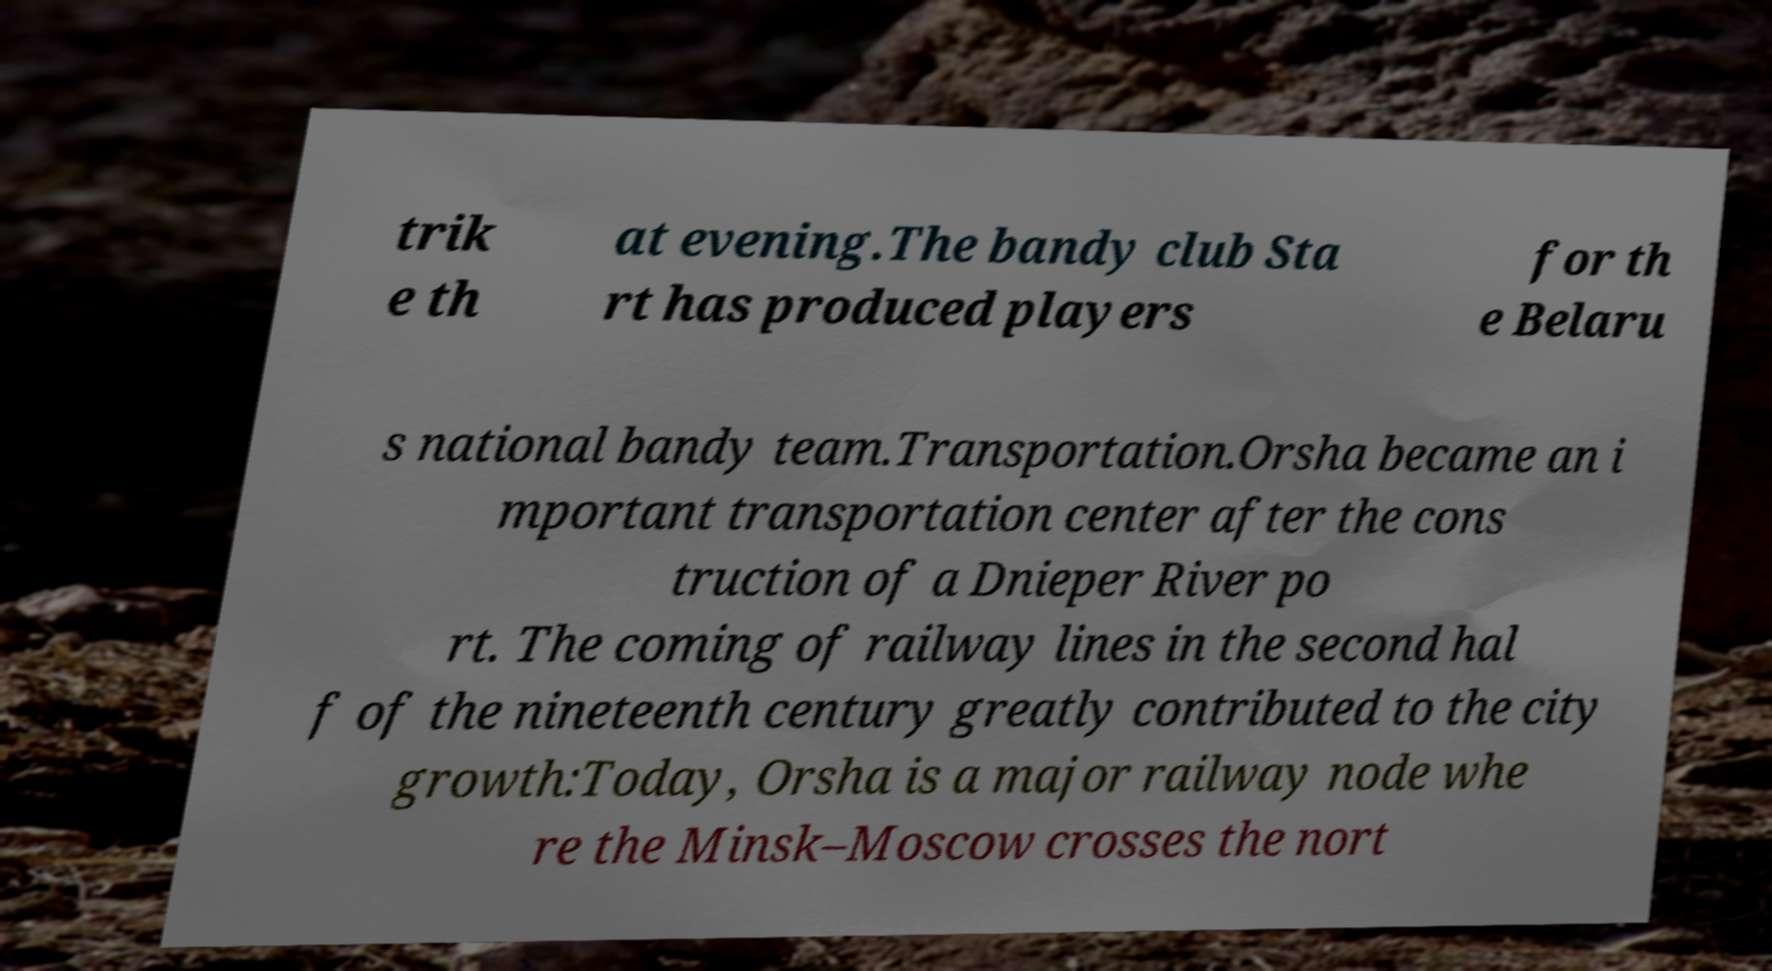Please read and relay the text visible in this image. What does it say? trik e th at evening.The bandy club Sta rt has produced players for th e Belaru s national bandy team.Transportation.Orsha became an i mportant transportation center after the cons truction of a Dnieper River po rt. The coming of railway lines in the second hal f of the nineteenth century greatly contributed to the city growth:Today, Orsha is a major railway node whe re the Minsk–Moscow crosses the nort 